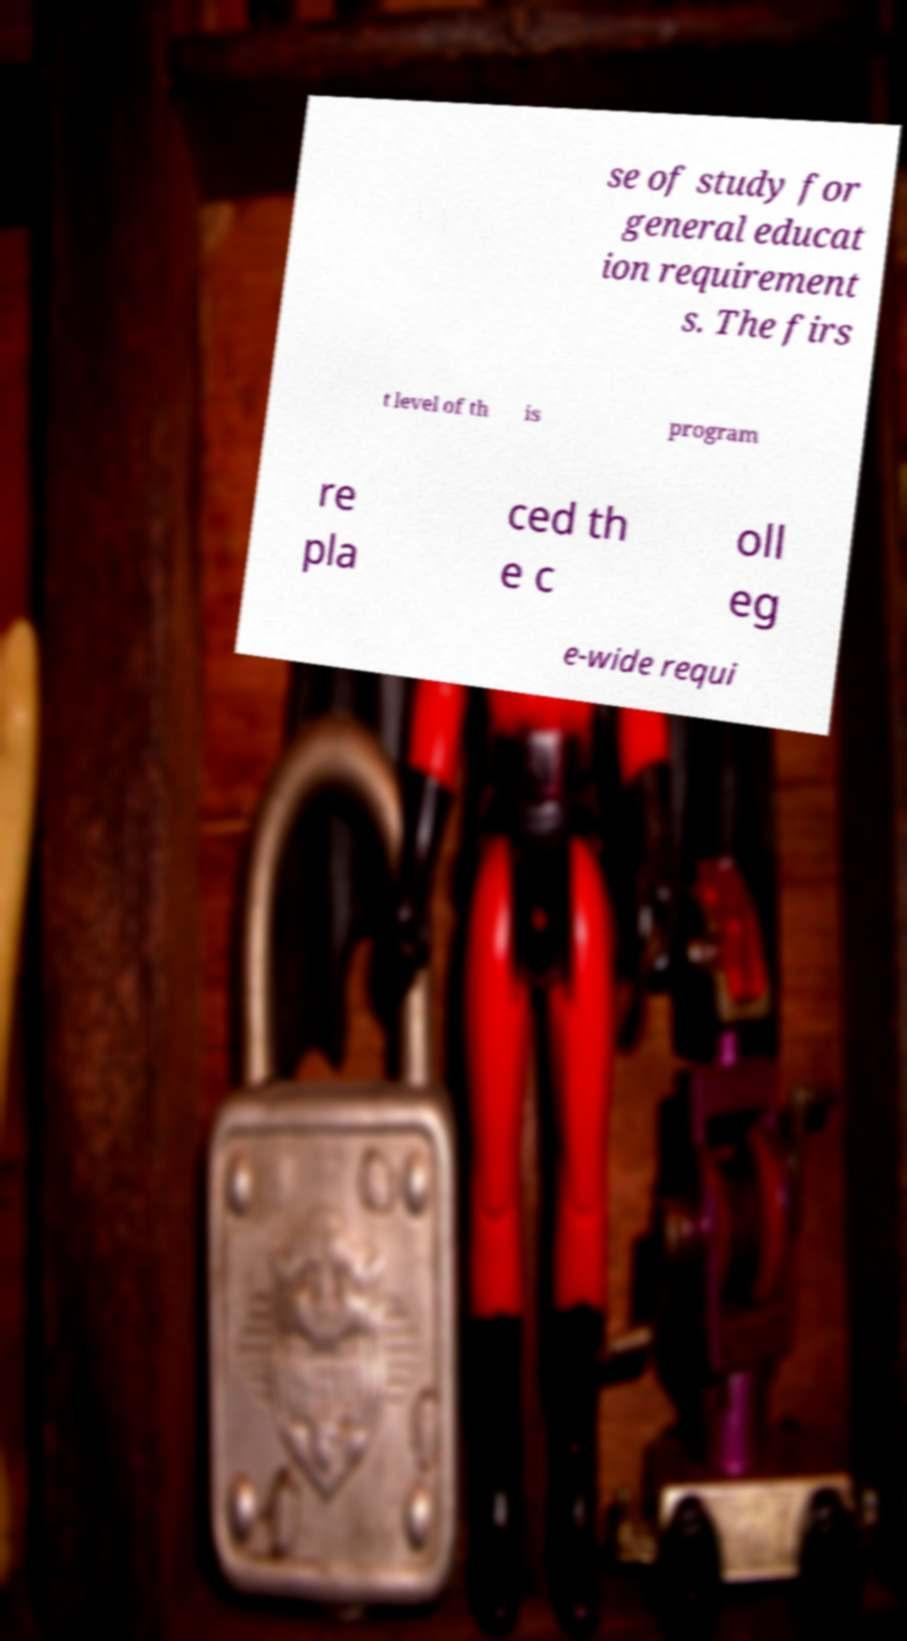Could you assist in decoding the text presented in this image and type it out clearly? se of study for general educat ion requirement s. The firs t level of th is program re pla ced th e c oll eg e-wide requi 